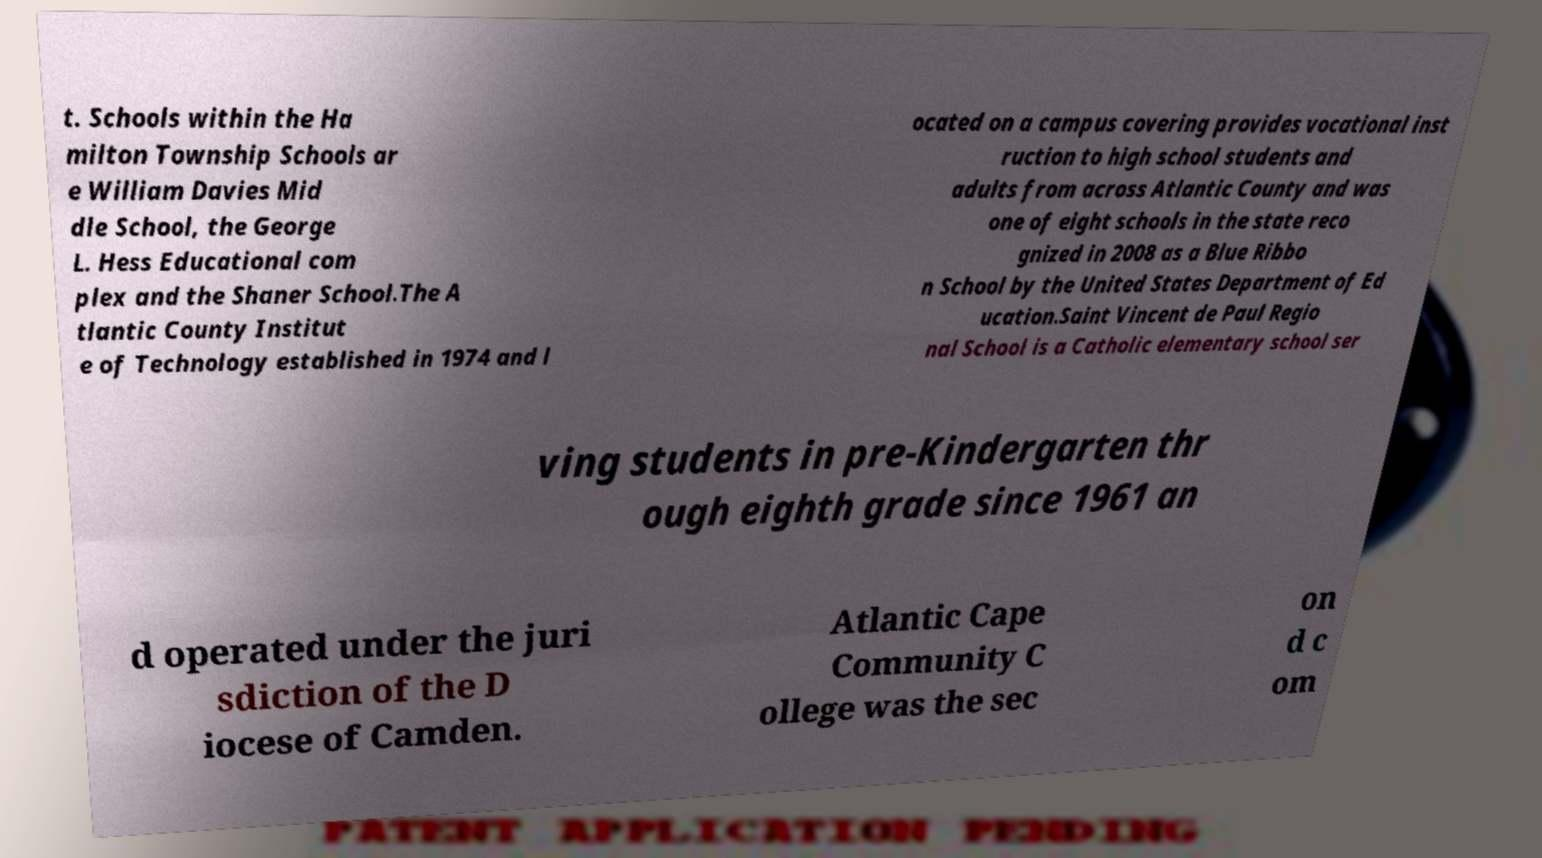What messages or text are displayed in this image? I need them in a readable, typed format. t. Schools within the Ha milton Township Schools ar e William Davies Mid dle School, the George L. Hess Educational com plex and the Shaner School.The A tlantic County Institut e of Technology established in 1974 and l ocated on a campus covering provides vocational inst ruction to high school students and adults from across Atlantic County and was one of eight schools in the state reco gnized in 2008 as a Blue Ribbo n School by the United States Department of Ed ucation.Saint Vincent de Paul Regio nal School is a Catholic elementary school ser ving students in pre-Kindergarten thr ough eighth grade since 1961 an d operated under the juri sdiction of the D iocese of Camden. Atlantic Cape Community C ollege was the sec on d c om 